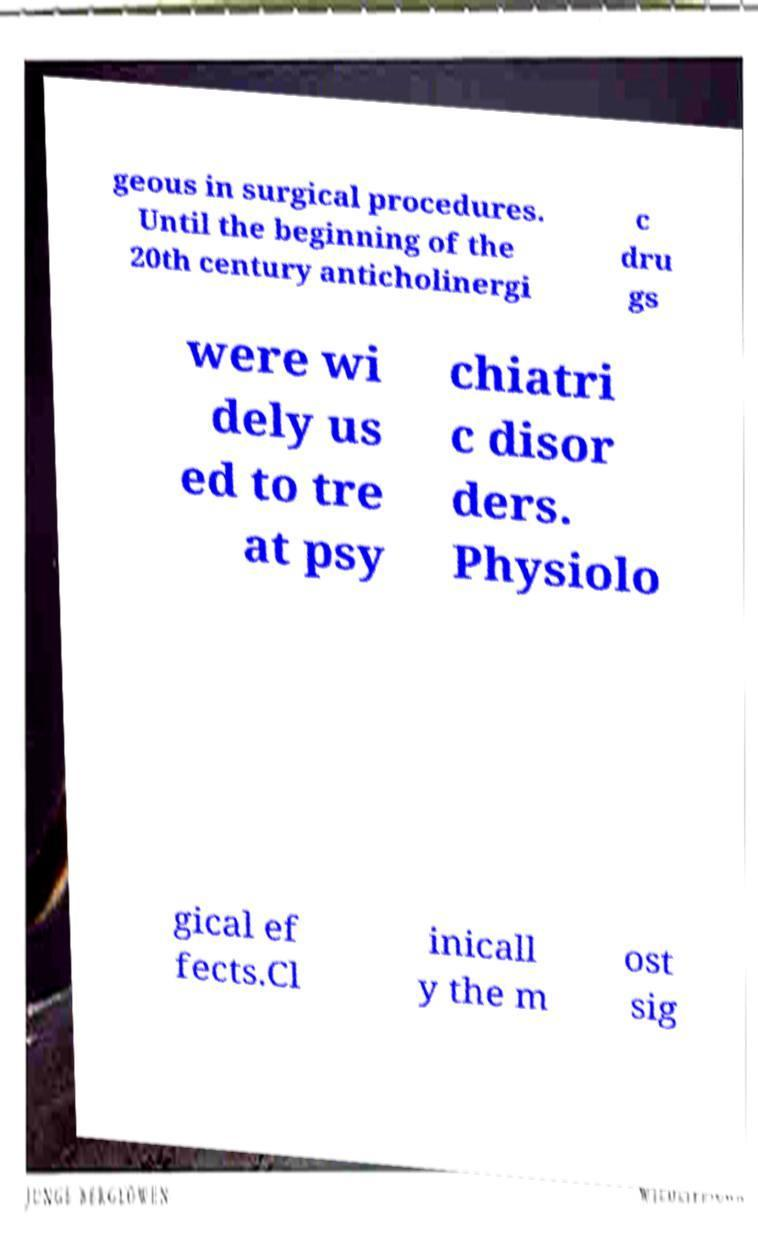What messages or text are displayed in this image? I need them in a readable, typed format. geous in surgical procedures. Until the beginning of the 20th century anticholinergi c dru gs were wi dely us ed to tre at psy chiatri c disor ders. Physiolo gical ef fects.Cl inicall y the m ost sig 